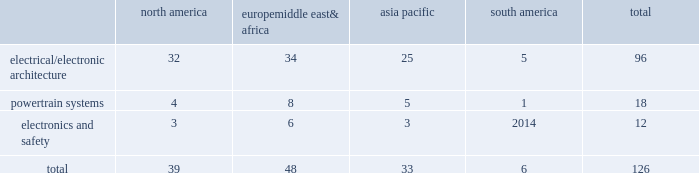Taxing authorities could challenge our historical and future tax positions .
Our future effective tax rates could be affected by changes in the mix of earnings in countries with differing statutory rates and changes in tax laws or their interpretation including changes related to tax holidays or tax incentives .
Our taxes could increase if certain tax holidays or incentives are not renewed upon expiration , or if tax rates or regimes applicable to us in such jurisdictions are otherwise increased .
The amount of tax we pay is subject to our interpretation of applicable tax laws in the jurisdictions in which we file .
We have taken and will continue to take tax positions based on our interpretation of such tax laws .
In particular , we will seek to organize and operate ourselves in such a way that we are and remain tax resident in the united kingdom .
Additionally , in determining the adequacy of our provision for income taxes , we regularly assess the likelihood of adverse outcomes resulting from tax examinations .
While it is often difficult to predict the final outcome or the timing of the resolution of a tax examination , our reserves for uncertain tax benefits reflect the outcome of tax positions that are more likely than not to occur .
While we believe that we have complied with all applicable tax laws , there can be no assurance that a taxing authority will not have a different interpretation of the law and assess us with additional taxes .
Should additional taxes be assessed , this may result in a material adverse effect on our results of operations and financial condition .
Item 1b .
Unresolved staff comments we have no unresolved sec staff comments to report .
Item 2 .
Properties as of december 31 , 2016 , we owned or leased 126 major manufacturing sites and 15 major technical centers .
A manufacturing site may include multiple plants and may be wholly or partially owned or leased .
We also have many smaller manufacturing sites , sales offices , warehouses , engineering centers , joint ventures and other investments strategically located throughout the world .
We have a presence in 46 countries .
The table shows the regional distribution of our major manufacturing sites by the operating segment that uses such facilities : north america europe , middle east & africa asia pacific south america total .
In addition to these manufacturing sites , we had 15 major technical centers : five in north america ; five in europe , middle east and africa ; four in asia pacific ; and one in south america .
Of our 126 major manufacturing sites and 15 major technical centers , which include facilities owned or leased by our consolidated subsidiaries , 75 are primarily owned and 66 are primarily leased .
We frequently review our real estate portfolio and develop footprint strategies to support our customers 2019 global plans , while at the same time supporting our technical needs and controlling operating expenses .
We believe our evolving portfolio will meet current and anticipated future needs .
Item 3 .
Legal proceedings we are from time to time subject to various actions , claims , suits , government investigations , and other proceedings incidental to our business , including those arising out of alleged defects , breach of contracts , competition and antitrust matters , product warranties , intellectual property matters , personal injury claims and employment-related matters .
It is our opinion that the outcome of such matters will not have a material adverse impact on our consolidated financial position , results of operations , or cash flows .
With respect to warranty matters , although we cannot ensure that the future costs of warranty claims by customers will not be material , we believe our established reserves are adequate to cover potential warranty settlements .
However , the final amounts required to resolve these matters could differ materially from our recorded estimates. .
What percentage of major manufacturing sites are in asia pacific? 
Computations: (33 / 126)
Answer: 0.2619. 